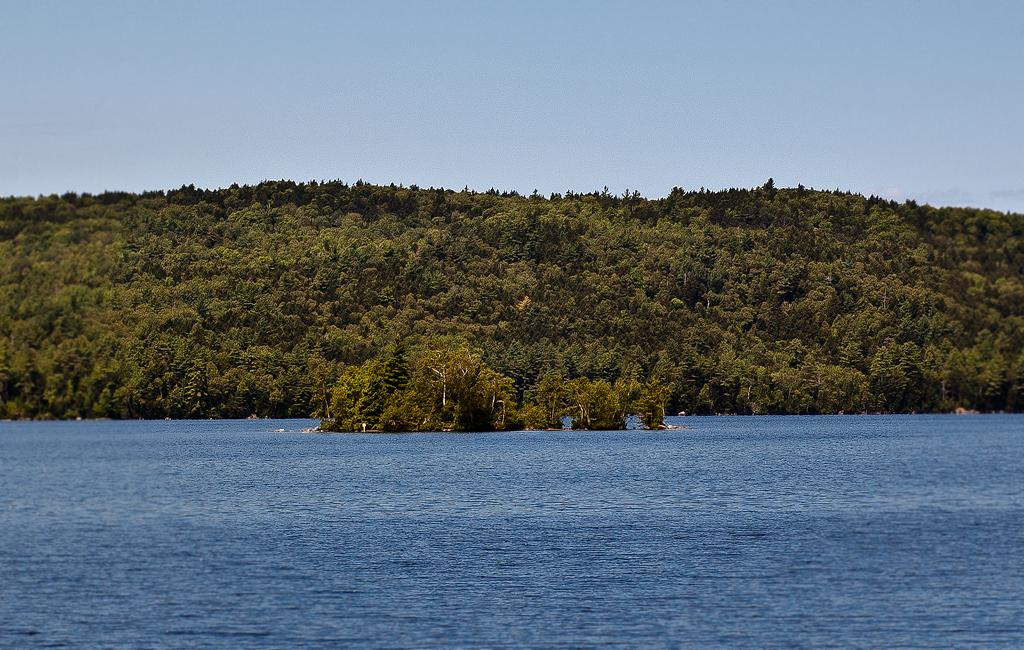What type of vegetation can be seen in the image? There are trees in the image. What large body of water is visible in the image? There is an ocean visible in the image. What part of the natural environment is visible in the image? The sky is visible in the image. What type of payment is being made in the image? There is no payment being made in the image; it features trees, an ocean, and the sky. Can you describe the twig that is being used by the police officer in the image? There is no police officer or twig present in the image. 